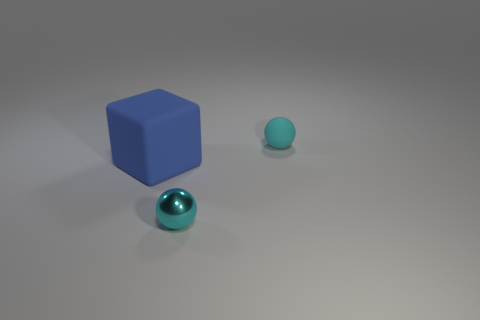There is a thing that is in front of the blue block; how many tiny matte balls are behind it? 1 